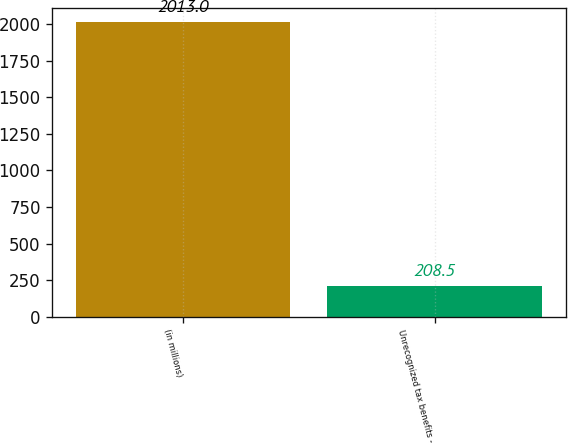Convert chart to OTSL. <chart><loc_0><loc_0><loc_500><loc_500><bar_chart><fcel>(in millions)<fcel>Unrecognized tax benefits -<nl><fcel>2013<fcel>208.5<nl></chart> 